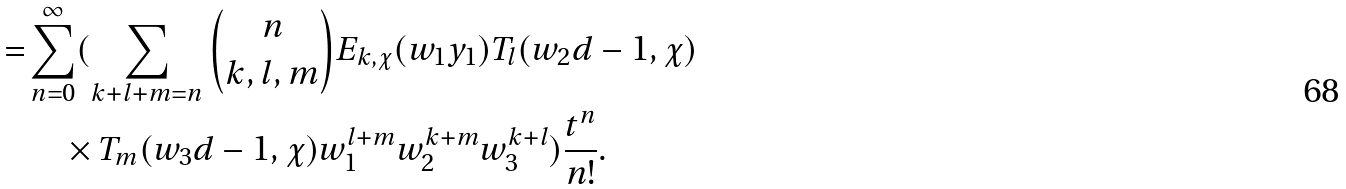<formula> <loc_0><loc_0><loc_500><loc_500>= & \sum _ { n = 0 } ^ { \infty } ( \sum _ { k + l + m = n } \binom { n } { k , l , m } E _ { k , \chi } ( w _ { 1 } y _ { 1 } ) T _ { l } ( w _ { 2 } d - 1 , \chi ) \\ & \quad \times T _ { m } ( w _ { 3 } d - 1 , \chi ) w _ { 1 } ^ { l + m } w _ { 2 } ^ { k + m } w _ { 3 } ^ { k + l } ) \frac { t ^ { n } } { n ! } .</formula> 